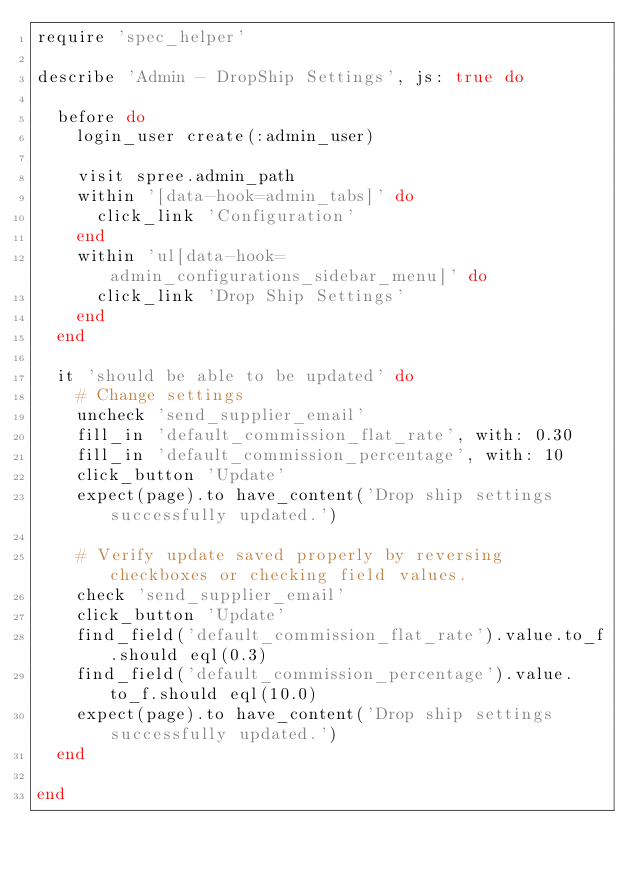<code> <loc_0><loc_0><loc_500><loc_500><_Ruby_>require 'spec_helper'

describe 'Admin - DropShip Settings', js: true do

  before do
    login_user create(:admin_user)

    visit spree.admin_path
    within '[data-hook=admin_tabs]' do
      click_link 'Configuration'
    end
    within 'ul[data-hook=admin_configurations_sidebar_menu]' do
      click_link 'Drop Ship Settings'
    end
  end

  it 'should be able to be updated' do
    # Change settings
    uncheck 'send_supplier_email'
    fill_in 'default_commission_flat_rate', with: 0.30
    fill_in 'default_commission_percentage', with: 10
    click_button 'Update'
    expect(page).to have_content('Drop ship settings successfully updated.')

    # Verify update saved properly by reversing checkboxes or checking field values.
    check 'send_supplier_email'
    click_button 'Update'
    find_field('default_commission_flat_rate').value.to_f.should eql(0.3)
    find_field('default_commission_percentage').value.to_f.should eql(10.0)
    expect(page).to have_content('Drop ship settings successfully updated.')
  end

end
</code> 